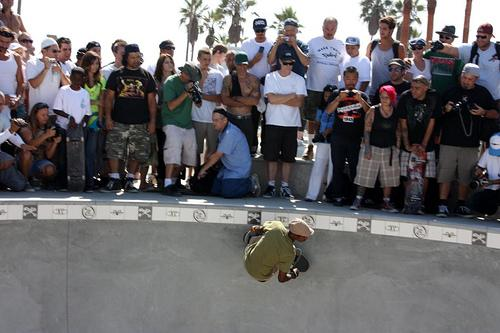What style of skateboarding is this?

Choices:
A) street
B) park
C) freestyle
D) vert vert 